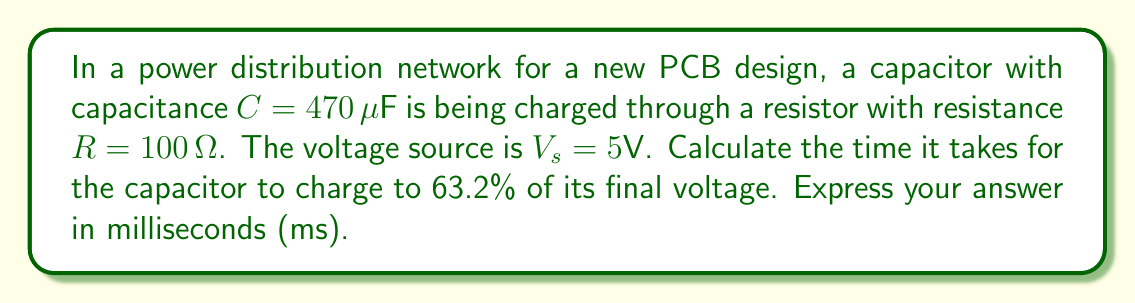Solve this math problem. To solve this problem, we need to use the first-order differential equation that describes the charging of a capacitor in an RC circuit:

$$\frac{dV_c}{dt} + \frac{1}{RC}V_c = \frac{V_s}{RC}$$

where $V_c$ is the voltage across the capacitor, $t$ is time, $R$ is resistance, $C$ is capacitance, and $V_s$ is the source voltage.

The solution to this differential equation is:

$$V_c(t) = V_s(1 - e^{-t/RC})$$

The time constant $\tau$ of an RC circuit is defined as:

$$\tau = RC$$

At time $t = \tau$, the capacitor reaches 63.2% of its final voltage. This is because:

$$V_c(\tau) = V_s(1 - e^{-1}) \approx 0.632V_s$$

Therefore, we need to calculate $\tau$:

$$\tau = RC = (100 \Omega)(470 \times 10^{-6} F) = 0.047 \text{ seconds}$$

To convert this to milliseconds, we multiply by 1000:

$$0.047 \text{ seconds} \times 1000 = 47 \text{ ms}$$
Answer: $47 \text{ ms}$ 